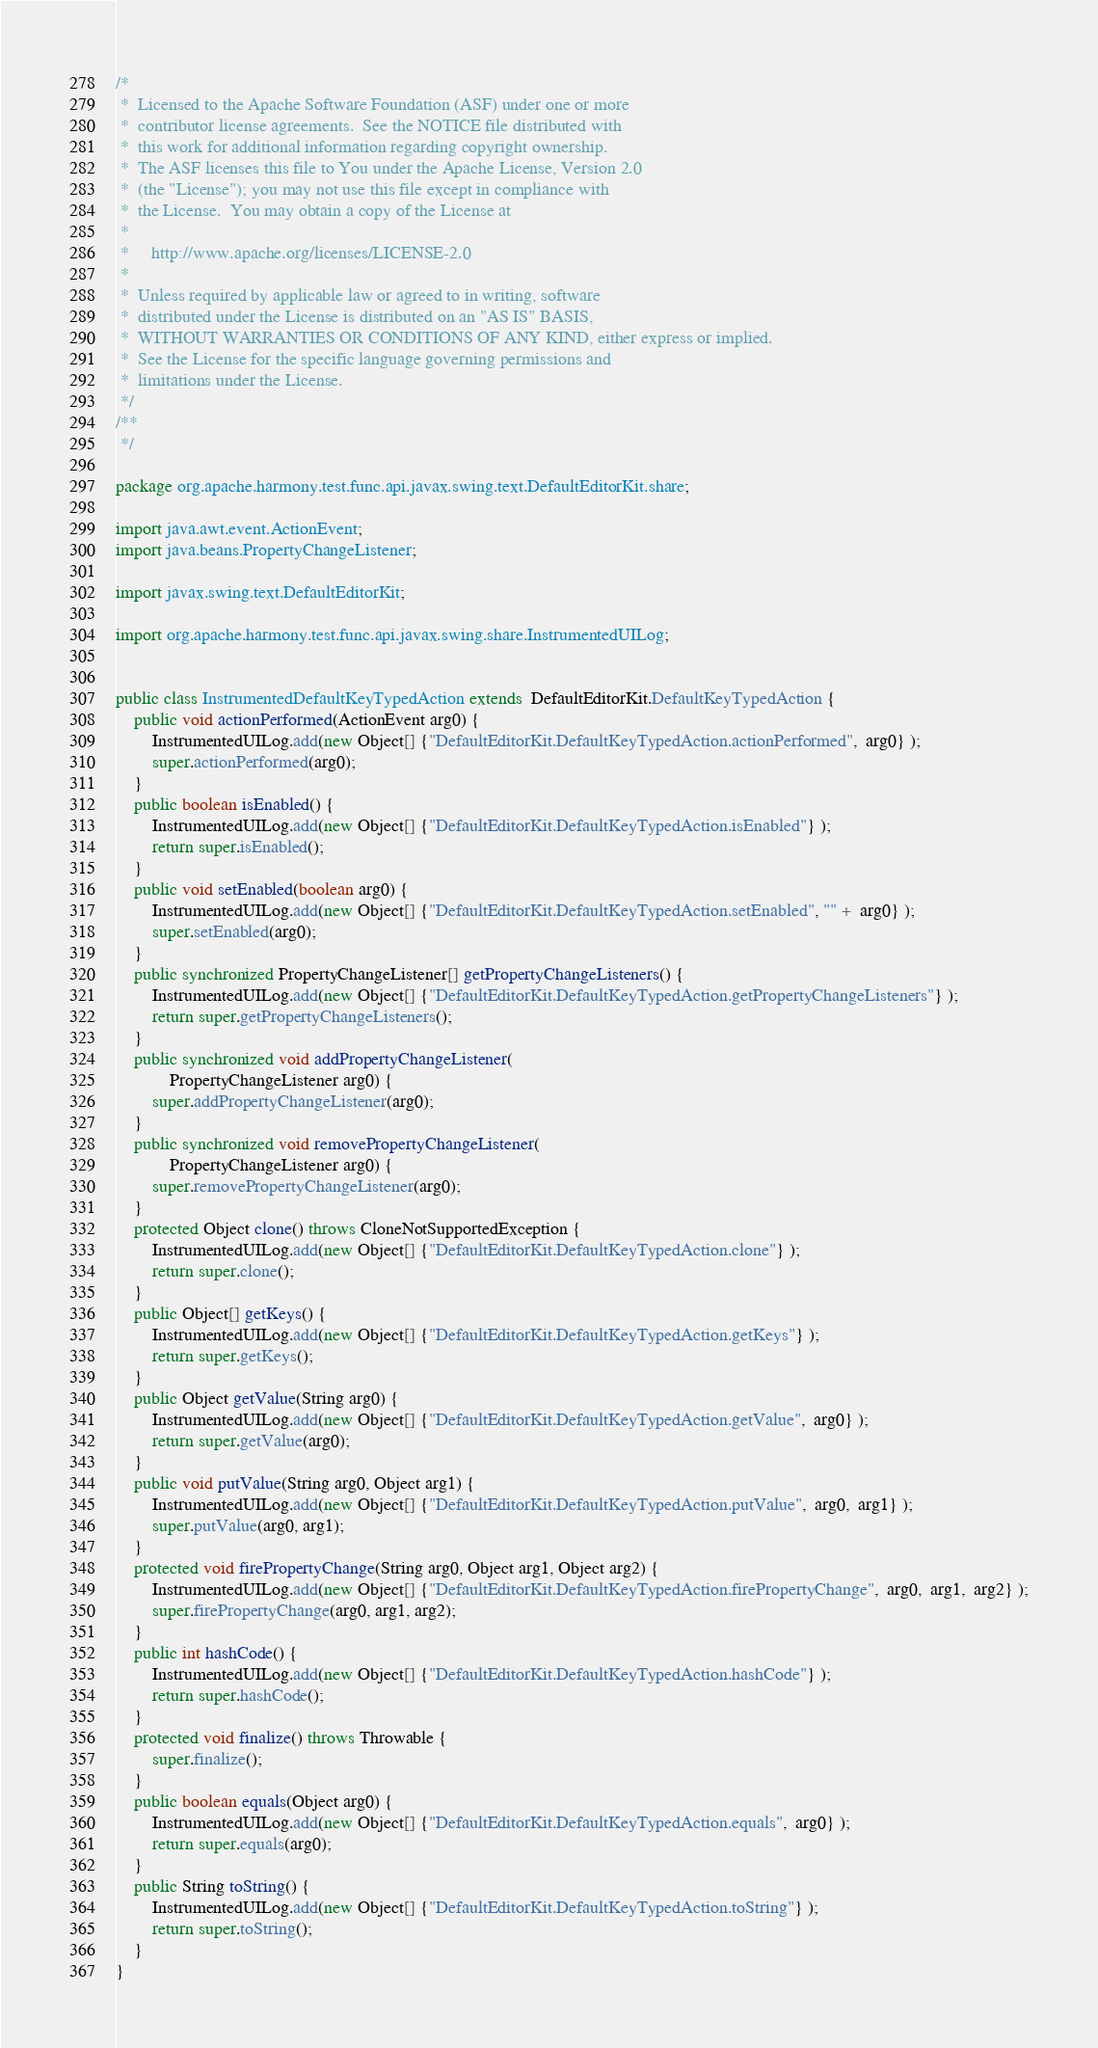Convert code to text. <code><loc_0><loc_0><loc_500><loc_500><_Java_>/*
 *  Licensed to the Apache Software Foundation (ASF) under one or more
 *  contributor license agreements.  See the NOTICE file distributed with
 *  this work for additional information regarding copyright ownership.
 *  The ASF licenses this file to You under the Apache License, Version 2.0
 *  (the "License"); you may not use this file except in compliance with
 *  the License.  You may obtain a copy of the License at
 *
 *     http://www.apache.org/licenses/LICENSE-2.0
 *
 *  Unless required by applicable law or agreed to in writing, software
 *  distributed under the License is distributed on an "AS IS" BASIS,
 *  WITHOUT WARRANTIES OR CONDITIONS OF ANY KIND, either express or implied.
 *  See the License for the specific language governing permissions and
 *  limitations under the License.
 */
/**
 */
 
package org.apache.harmony.test.func.api.javax.swing.text.DefaultEditorKit.share;

import java.awt.event.ActionEvent;
import java.beans.PropertyChangeListener;

import javax.swing.text.DefaultEditorKit;

import org.apache.harmony.test.func.api.javax.swing.share.InstrumentedUILog;


public class InstrumentedDefaultKeyTypedAction extends  DefaultEditorKit.DefaultKeyTypedAction {
    public void actionPerformed(ActionEvent arg0) {
        InstrumentedUILog.add(new Object[] {"DefaultEditorKit.DefaultKeyTypedAction.actionPerformed",  arg0} );
        super.actionPerformed(arg0);
    }
    public boolean isEnabled() {
        InstrumentedUILog.add(new Object[] {"DefaultEditorKit.DefaultKeyTypedAction.isEnabled"} );
        return super.isEnabled();
    }
    public void setEnabled(boolean arg0) {
        InstrumentedUILog.add(new Object[] {"DefaultEditorKit.DefaultKeyTypedAction.setEnabled", "" +  arg0} );
        super.setEnabled(arg0);
    }
    public synchronized PropertyChangeListener[] getPropertyChangeListeners() {
        InstrumentedUILog.add(new Object[] {"DefaultEditorKit.DefaultKeyTypedAction.getPropertyChangeListeners"} );
        return super.getPropertyChangeListeners();
    }
    public synchronized void addPropertyChangeListener(
            PropertyChangeListener arg0) {
        super.addPropertyChangeListener(arg0);
    }
    public synchronized void removePropertyChangeListener(
            PropertyChangeListener arg0) {
        super.removePropertyChangeListener(arg0);
    }
    protected Object clone() throws CloneNotSupportedException {
        InstrumentedUILog.add(new Object[] {"DefaultEditorKit.DefaultKeyTypedAction.clone"} );
        return super.clone();
    }
    public Object[] getKeys() {
        InstrumentedUILog.add(new Object[] {"DefaultEditorKit.DefaultKeyTypedAction.getKeys"} );
        return super.getKeys();
    }
    public Object getValue(String arg0) {
        InstrumentedUILog.add(new Object[] {"DefaultEditorKit.DefaultKeyTypedAction.getValue",  arg0} );
        return super.getValue(arg0);
    }
    public void putValue(String arg0, Object arg1) {
        InstrumentedUILog.add(new Object[] {"DefaultEditorKit.DefaultKeyTypedAction.putValue",  arg0,  arg1} );
        super.putValue(arg0, arg1);
    }
    protected void firePropertyChange(String arg0, Object arg1, Object arg2) {
        InstrumentedUILog.add(new Object[] {"DefaultEditorKit.DefaultKeyTypedAction.firePropertyChange",  arg0,  arg1,  arg2} );
        super.firePropertyChange(arg0, arg1, arg2);
    }
    public int hashCode() {
        InstrumentedUILog.add(new Object[] {"DefaultEditorKit.DefaultKeyTypedAction.hashCode"} );
        return super.hashCode();
    }
    protected void finalize() throws Throwable {
        super.finalize();
    }
    public boolean equals(Object arg0) {
        InstrumentedUILog.add(new Object[] {"DefaultEditorKit.DefaultKeyTypedAction.equals",  arg0} );
        return super.equals(arg0);
    }
    public String toString() {
        InstrumentedUILog.add(new Object[] {"DefaultEditorKit.DefaultKeyTypedAction.toString"} );
        return super.toString();
    }
}
</code> 